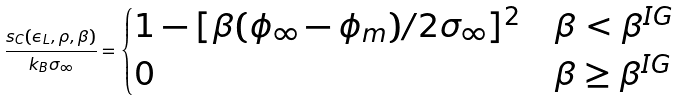<formula> <loc_0><loc_0><loc_500><loc_500>\frac { s _ { C } ( \epsilon _ { L } , \rho , \beta ) } { k _ { B } \sigma _ { \infty } } = \begin{cases} 1 - [ { \beta ( \phi _ { \infty } - \phi _ { m } ) } / { 2 \sigma _ { \infty } } ] ^ { 2 } & \beta < \beta ^ { I G } \\ 0 & \beta \geq \beta ^ { I G } \end{cases}</formula> 